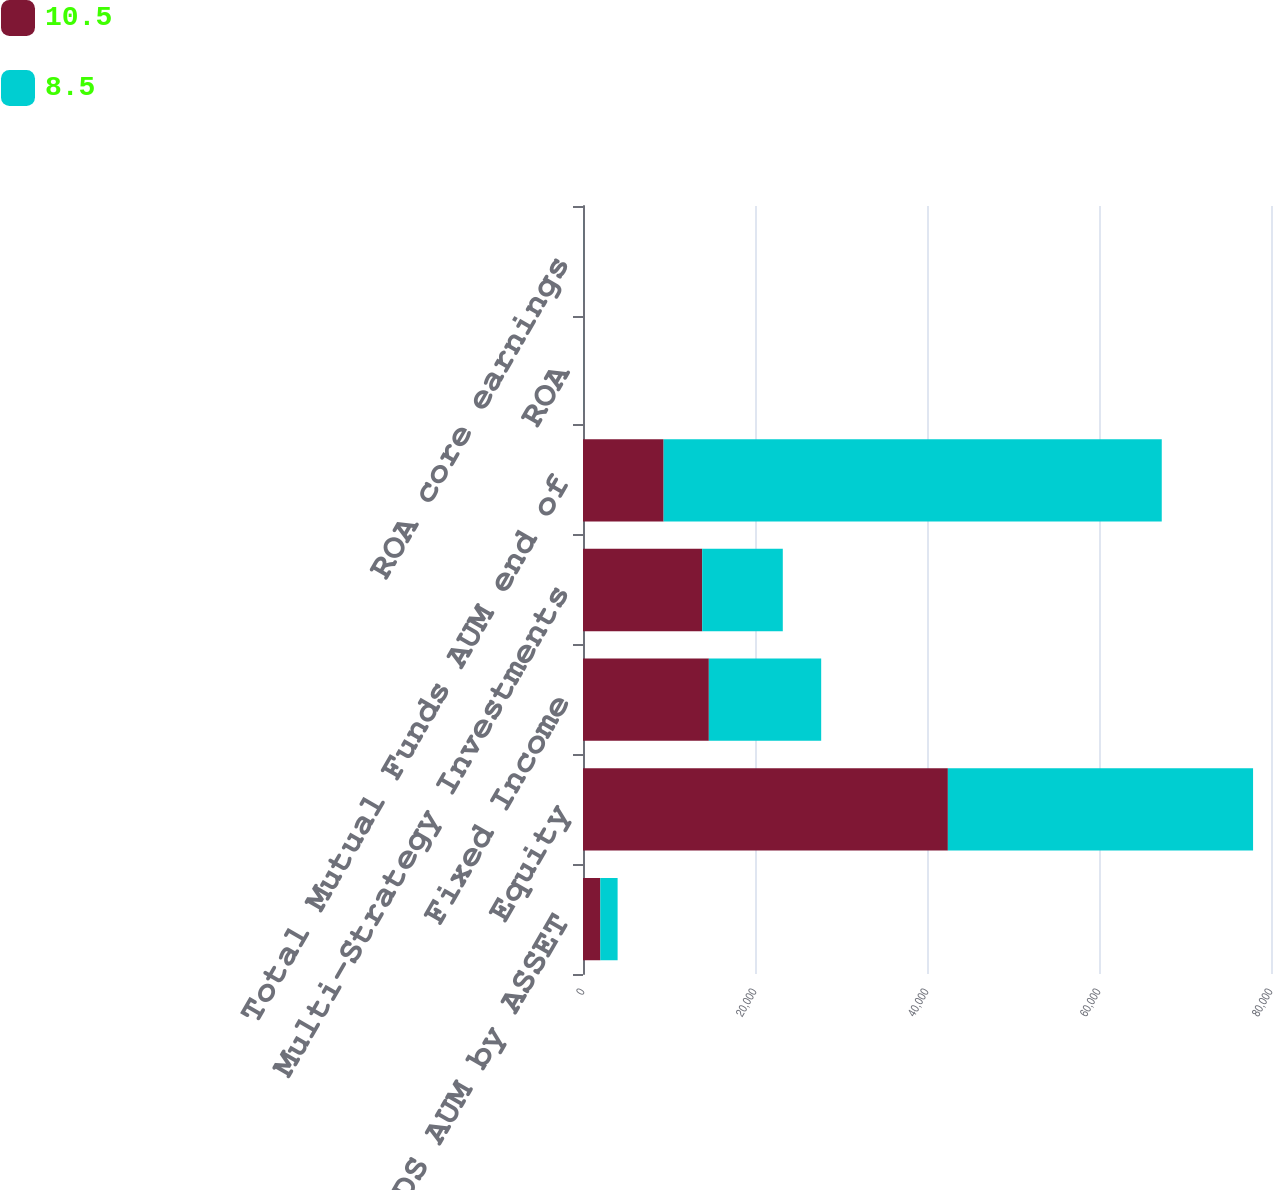Convert chart to OTSL. <chart><loc_0><loc_0><loc_500><loc_500><stacked_bar_chart><ecel><fcel>MUTUAL FUNDS AUM by ASSET<fcel>Equity<fcel>Fixed Income<fcel>Multi-Strategy Investments<fcel>Total Mutual Funds AUM end of<fcel>ROA<fcel>ROA core earnings<nl><fcel>10.5<fcel>2013<fcel>42426<fcel>14632<fcel>13860<fcel>9372<fcel>8.2<fcel>8.5<nl><fcel>8.5<fcel>2011<fcel>35489<fcel>13064<fcel>9372<fcel>57925<fcel>10.5<fcel>10.5<nl></chart> 